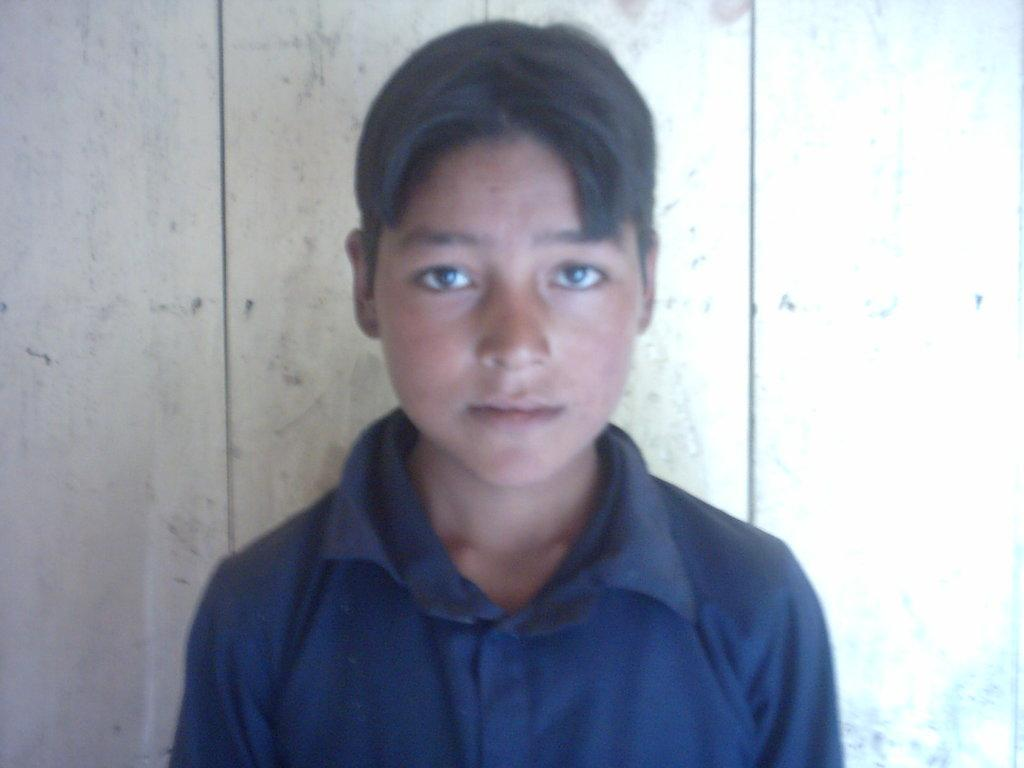What is the main subject of the image? There is a boy in the image. What is the boy wearing? The boy is wearing a navy blue t-shirt. What is the boy's posture in the image? The boy is standing. What can be seen in the background of the image? There is a wooden wall in the background of the image. How many giraffes can be seen in the image? There are no giraffes present in the image. What color are the boy's eyes in the image? The provided facts do not mention the color of the boy's eyes, so we cannot determine that information from the image. 